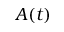<formula> <loc_0><loc_0><loc_500><loc_500>A ( t )</formula> 